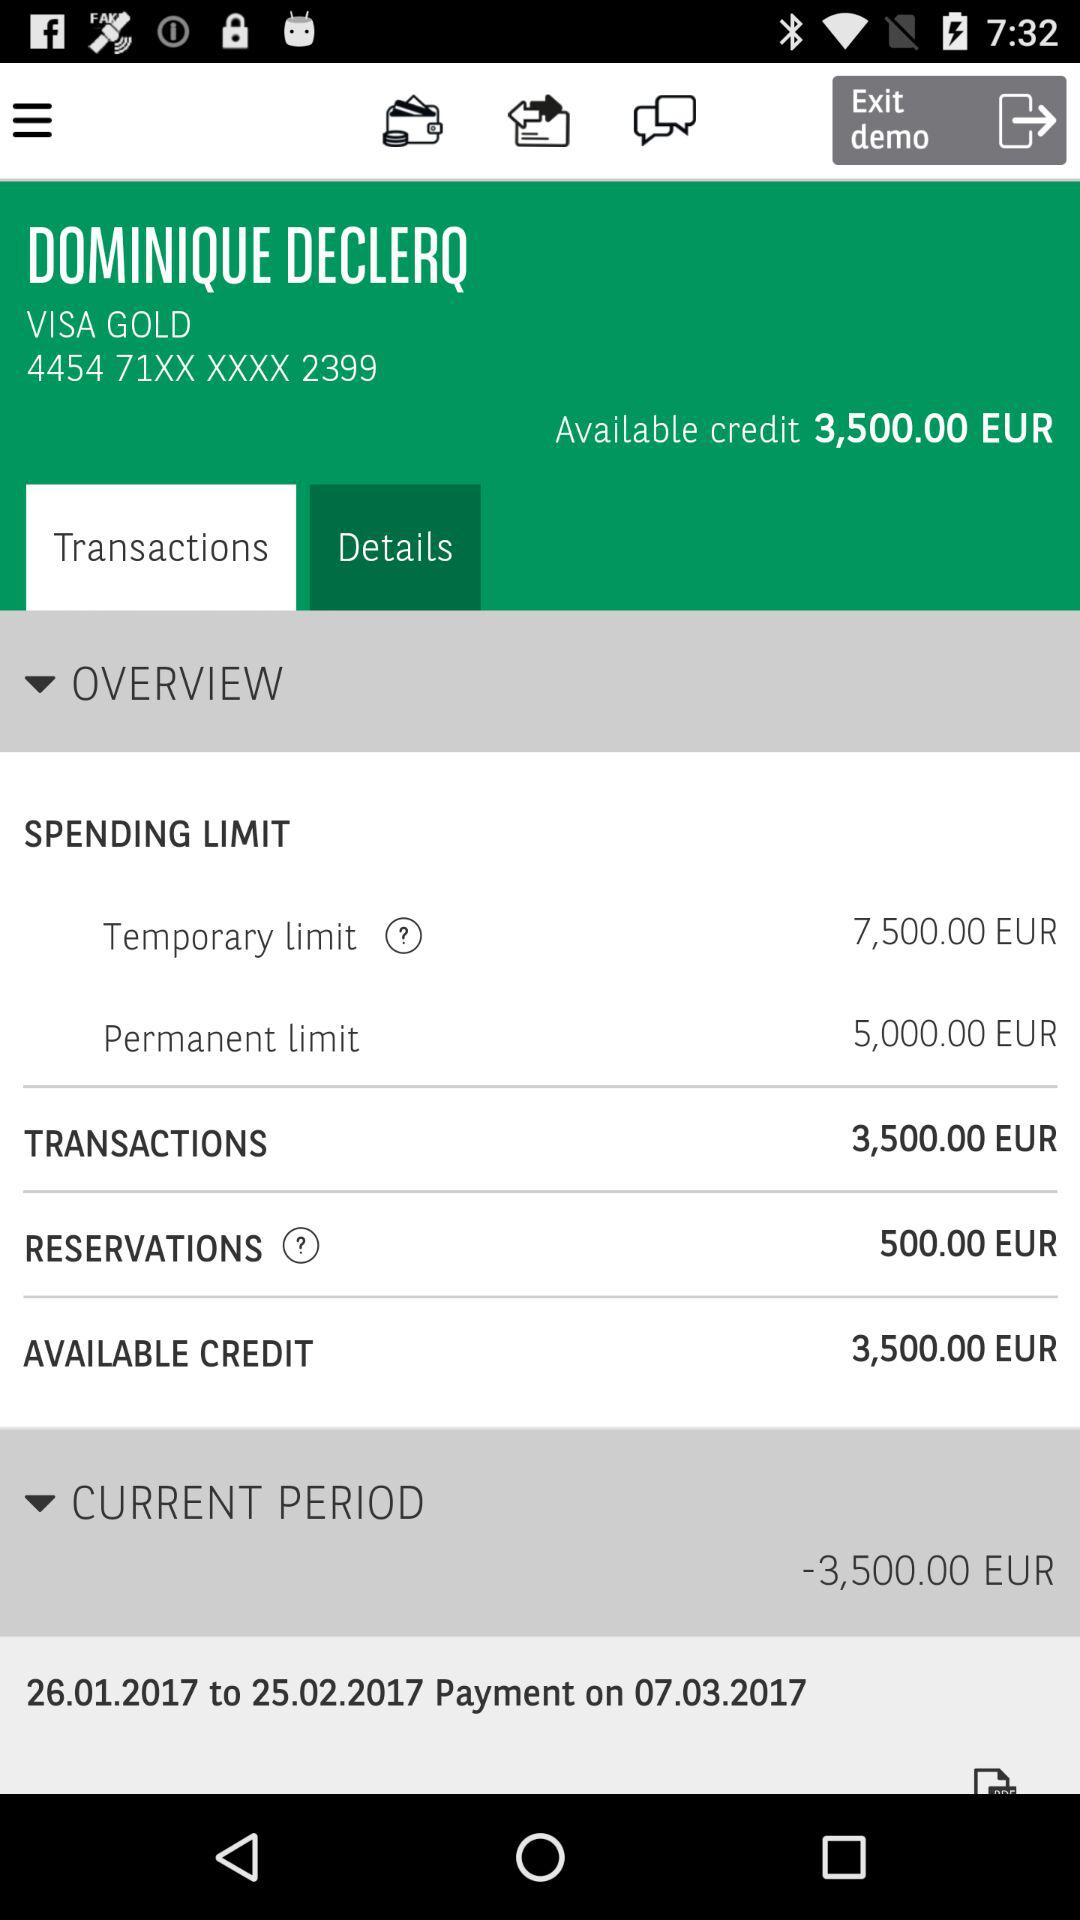What is the transaction amount? The transaction amount is 3,500.00 euros. 